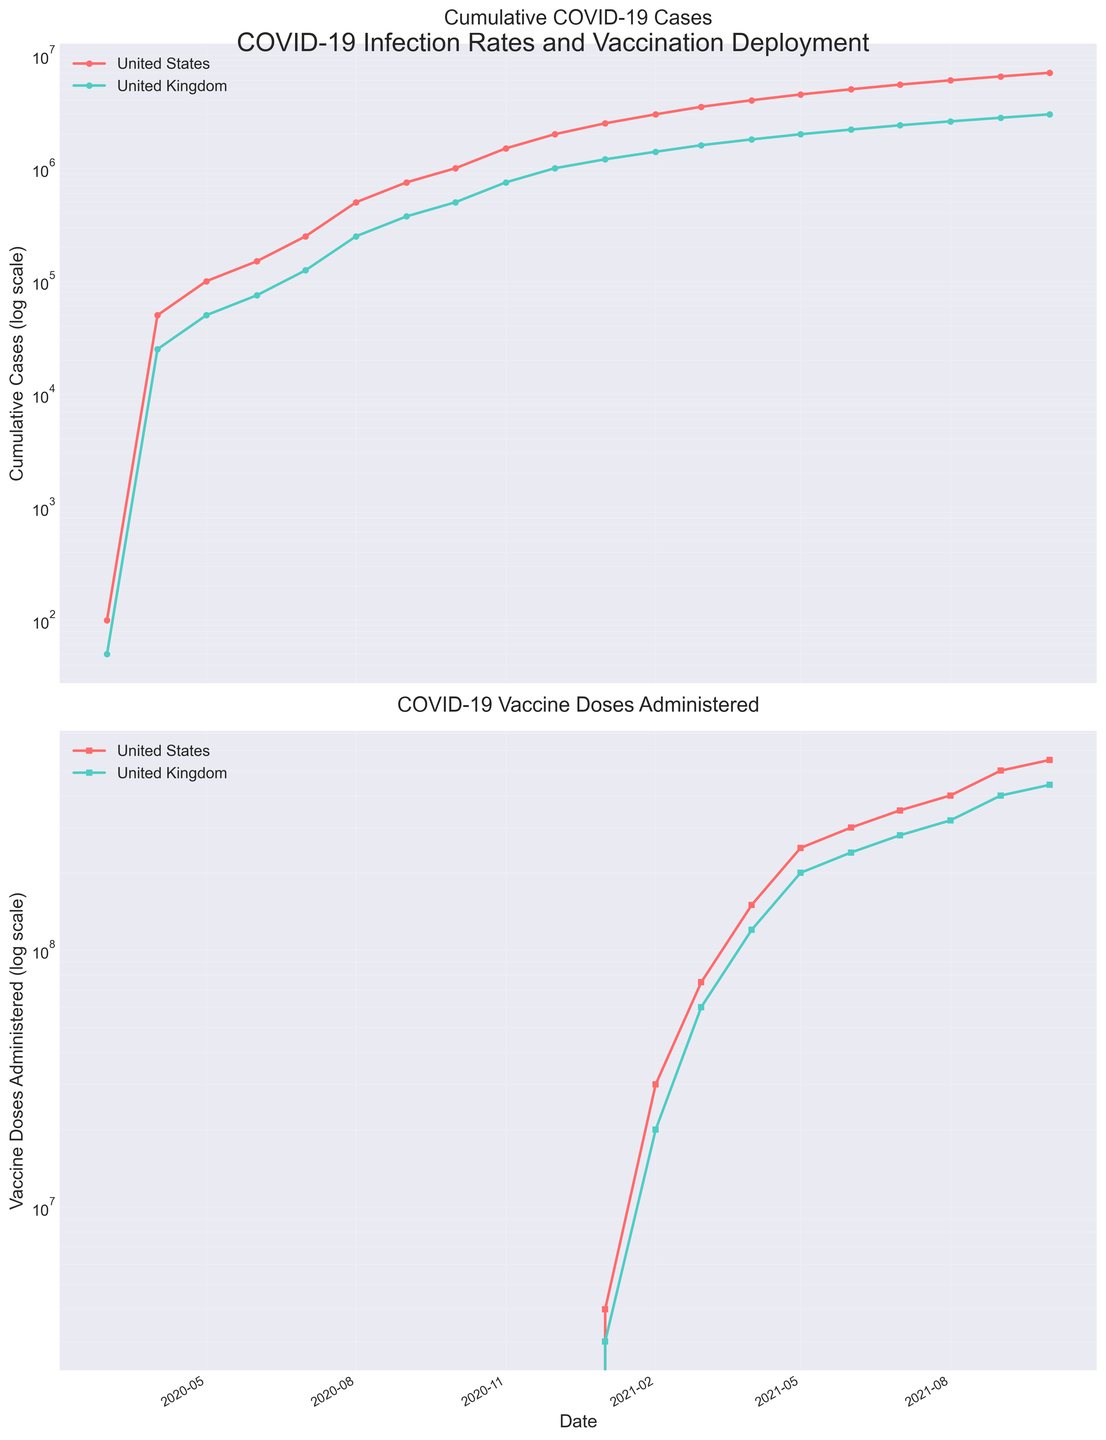Which country had a higher cumulative number of COVID-19 cases on January 1, 2021? On January 1, 2021, the cumulative cases for the United States and the United Kingdom can be found on the first subplot. The United States shows higher numbers compared to the United Kingdom.
Answer: United States How does the trend of cumulative COVID-19 cases differ between the United States and the United Kingdom? By observing the first subplot with a logarithmic scale, both countries show an initial exponential rise in cases, but the United States has a more significant increase post-vaccination (starting 2021), while the rise in the United Kingdom is more gradual.
Answer: U.S. rises faster post-vaccination, U.K. is more gradual What is the most significant change in the number of vaccine doses administered between consecutive months for the United States? Reviewing the second subplot, the biggest change in the slope (indicating a substantial increase) occurs between January 1, 2021, and February 1, 2021. The doses administered rise sharply from 4 million to 30 million.
Answer: 4 million to 30 million from Jan to Feb 2021 Which country reached the 1 million cumulative cases mark first? Observing the timeline in the first subplot, the United States reached the 1 million mark around October 1, 2020, while the United Kingdom reached it around December 1, 2020.
Answer: United States Compare the cumulative number of vaccine doses administered in April 2021 between the United States and the United Kingdom. In the second subplot, around April 1, 2021, the United States has administered approximately 150 million doses, while the United Kingdom has administered approximately 120 million doses.
Answer: United States When did the United Kingdom surpass 100,000 cumulative COVID-19 cases? Referring to the logarithmic representation of cumulative cases in the first subplot, the United Kingdom surpassed 100,000 cases around July 2020.
Answer: July 2020 What is the relative difference in the cumulative number of COVID-19 cases between the United States and the United Kingdom on May 1, 2021? On May 1, 2021, the United States had approximately 4.5 million cases, and the United Kingdom had approximately 2 million. The relative difference is (4.5 million - 2 million) / 4.5 million = 55.56%.
Answer: 55.56% By the end of the plotted period, which country had administered more vaccine doses? Observing the last data points in the second subplot, as of October 1, 2021, the United States had administered 550 million doses, compared to the United Kingdom's 440 million doses.
Answer: United States What's the general trend observed in COVID-19 case numbers once the vaccine deployment began for both countries in early 2021? The first subplot shows a slowing in the rate of increase in cumulative cases for both countries starting from 2021, suggesting that the vaccination effort may have contributed to controlling the infection rate.
Answer: Slowing growth rate in 2021 When did the cumulative doses administered in the United Kingdom surpass 100 million? Referring to the second subplot, the cumulative doses in the United Kingdom surpassed 100 million around April 2021.
Answer: April 2021 